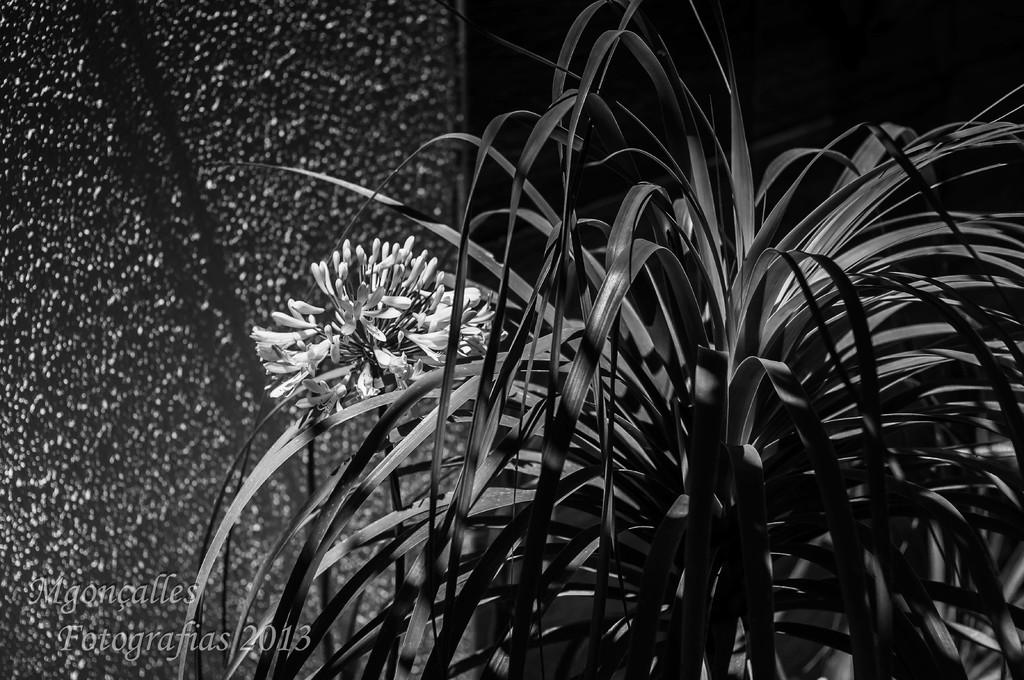What type of plant is visible in the image? There is a flower in the image, which is a type of plant. What else can be seen in the image besides the flower? There is a plant and a wall in the background visible in the image. Is there any text present in the image? Yes, there is some text at the bottom of the image. How many girls are interacting with the beast in the image? There is no beast or girls present in the image; it only features a flower, a plant, a wall, and some text. 